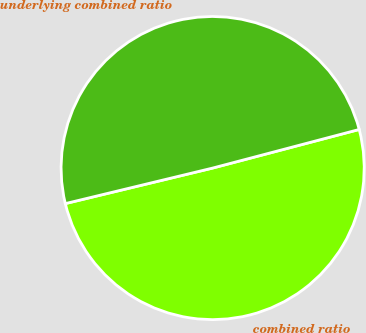Convert chart to OTSL. <chart><loc_0><loc_0><loc_500><loc_500><pie_chart><fcel>combined ratio<fcel>underlying combined ratio<nl><fcel>50.33%<fcel>49.67%<nl></chart> 